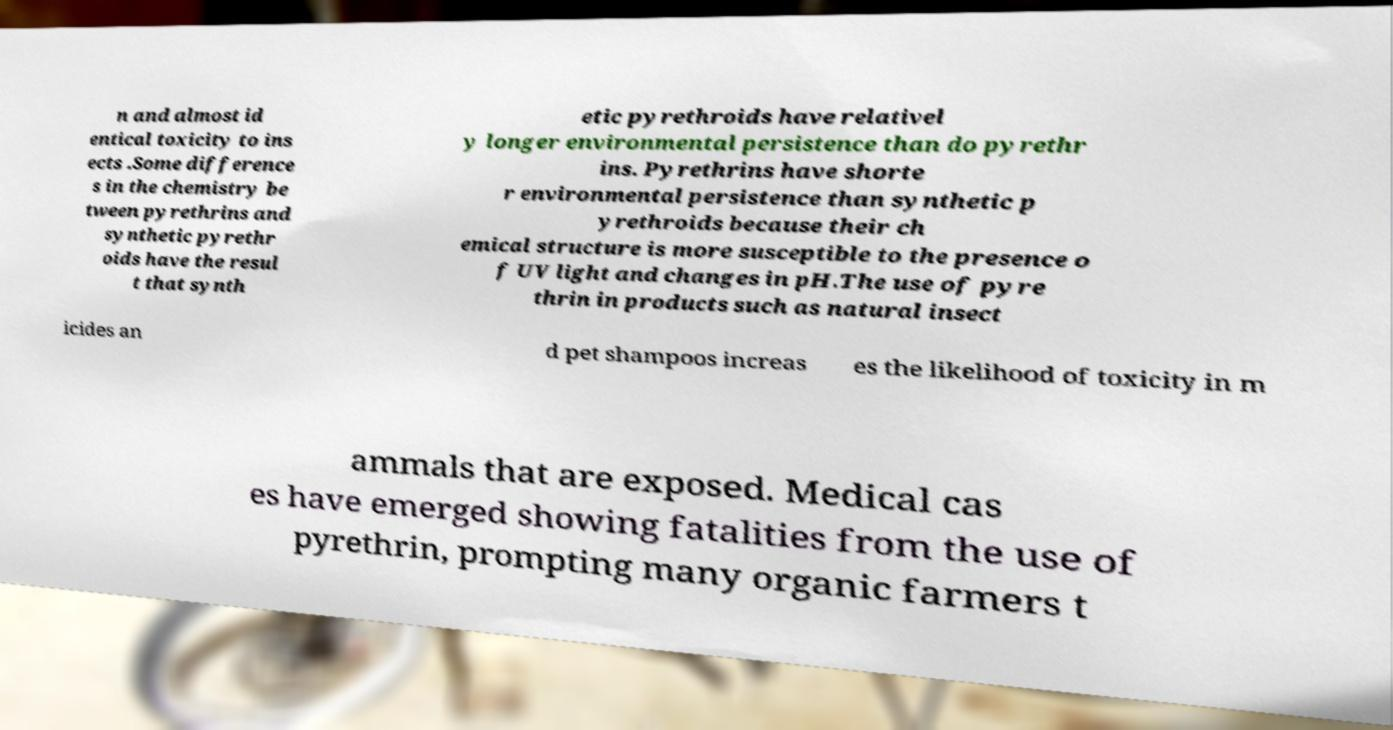What messages or text are displayed in this image? I need them in a readable, typed format. n and almost id entical toxicity to ins ects .Some difference s in the chemistry be tween pyrethrins and synthetic pyrethr oids have the resul t that synth etic pyrethroids have relativel y longer environmental persistence than do pyrethr ins. Pyrethrins have shorte r environmental persistence than synthetic p yrethroids because their ch emical structure is more susceptible to the presence o f UV light and changes in pH.The use of pyre thrin in products such as natural insect icides an d pet shampoos increas es the likelihood of toxicity in m ammals that are exposed. Medical cas es have emerged showing fatalities from the use of pyrethrin, prompting many organic farmers t 